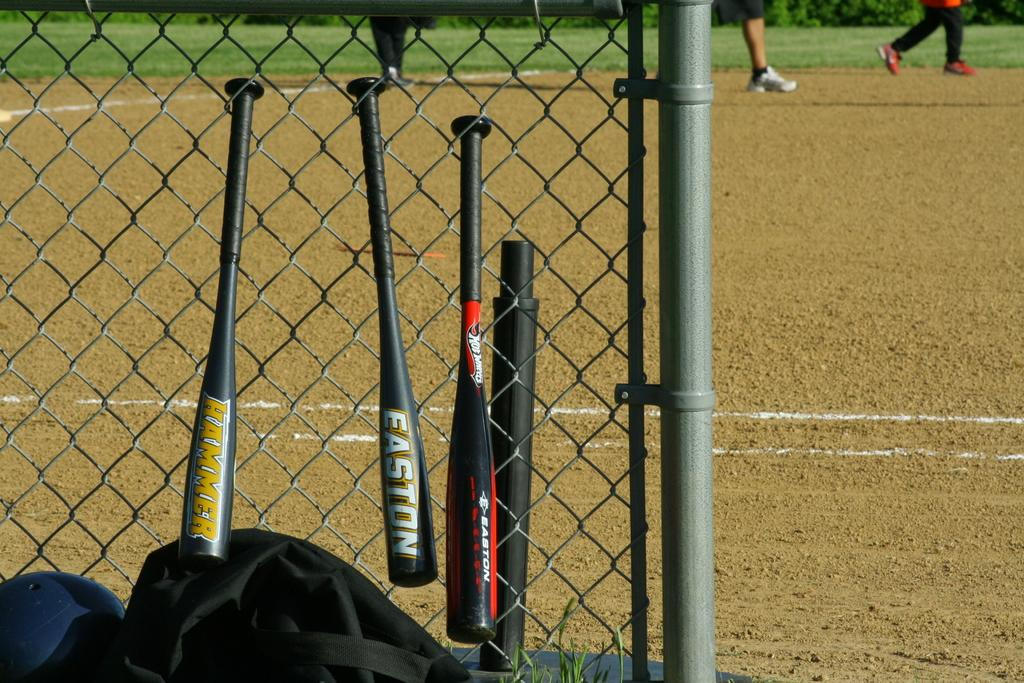What type of structure is present in the image? There is a mesh wall with a pole in the image. What is hanging on the mesh wall? Bats are hanging on the mesh wall. What object is located near the mesh wall? There is a bag near the mesh wall. Can you describe the background of the image? People are visible in the background of the image. What type of vegetation is present in the image? Grass is present in the image. What type of stem can be seen growing from the mesh wall in the image? There is no stem growing from the mesh wall in the image. What attraction is nearby that might draw people to the area? The provided facts do not mention any nearby attractions, so it cannot be determined from the image. 